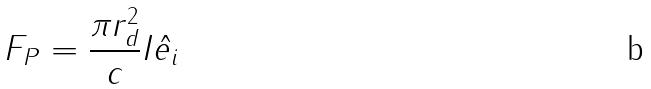Convert formula to latex. <formula><loc_0><loc_0><loc_500><loc_500>F _ { P } = \frac { \pi r _ { d } ^ { 2 } } { c } I \hat { e _ { i } }</formula> 